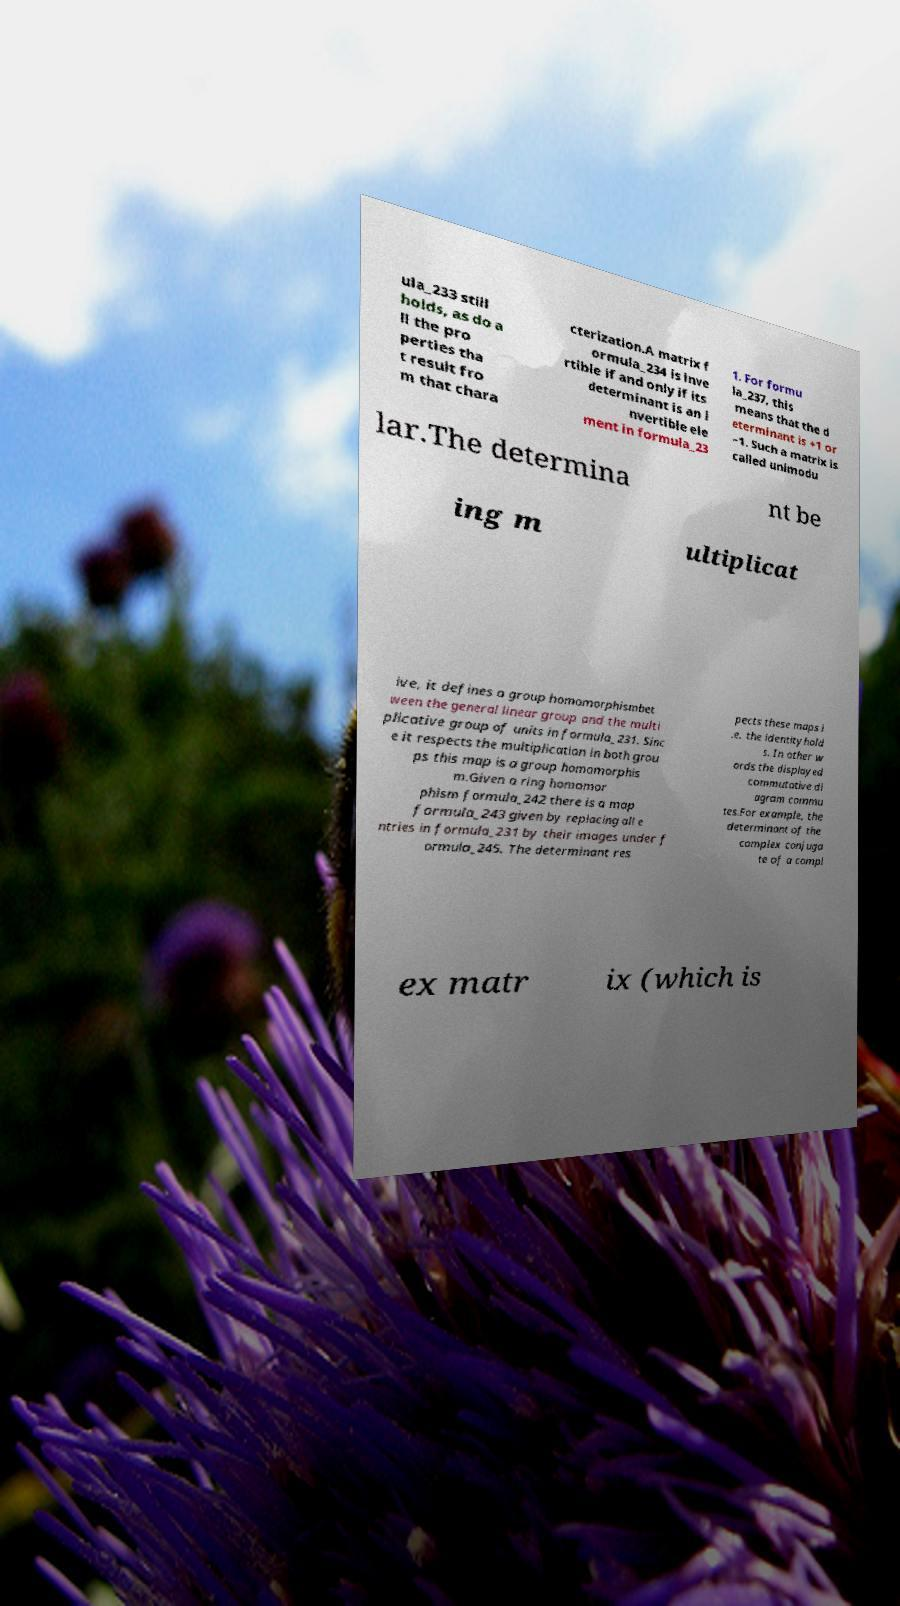Please identify and transcribe the text found in this image. ula_233 still holds, as do a ll the pro perties tha t result fro m that chara cterization.A matrix f ormula_234 is inve rtible if and only if its determinant is an i nvertible ele ment in formula_23 1. For formu la_237, this means that the d eterminant is +1 or −1. Such a matrix is called unimodu lar.The determina nt be ing m ultiplicat ive, it defines a group homomorphismbet ween the general linear group and the multi plicative group of units in formula_231. Sinc e it respects the multiplication in both grou ps this map is a group homomorphis m.Given a ring homomor phism formula_242 there is a map formula_243 given by replacing all e ntries in formula_231 by their images under f ormula_245. The determinant res pects these maps i .e. the identityhold s. In other w ords the displayed commutative di agram commu tes.For example, the determinant of the complex conjuga te of a compl ex matr ix (which is 